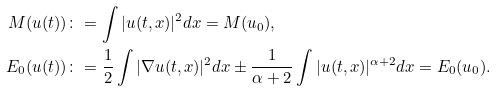<formula> <loc_0><loc_0><loc_500><loc_500>M ( u ( t ) ) & \colon = \int | u ( t , x ) | ^ { 2 } d x = M ( u _ { 0 } ) , \\ E _ { 0 } ( u ( t ) ) & \colon = \frac { 1 } { 2 } \int | \nabla u ( t , x ) | ^ { 2 } d x \pm \frac { 1 } { \alpha + 2 } \int | u ( t , x ) | ^ { \alpha + 2 } d x = E _ { 0 } ( u _ { 0 } ) .</formula> 